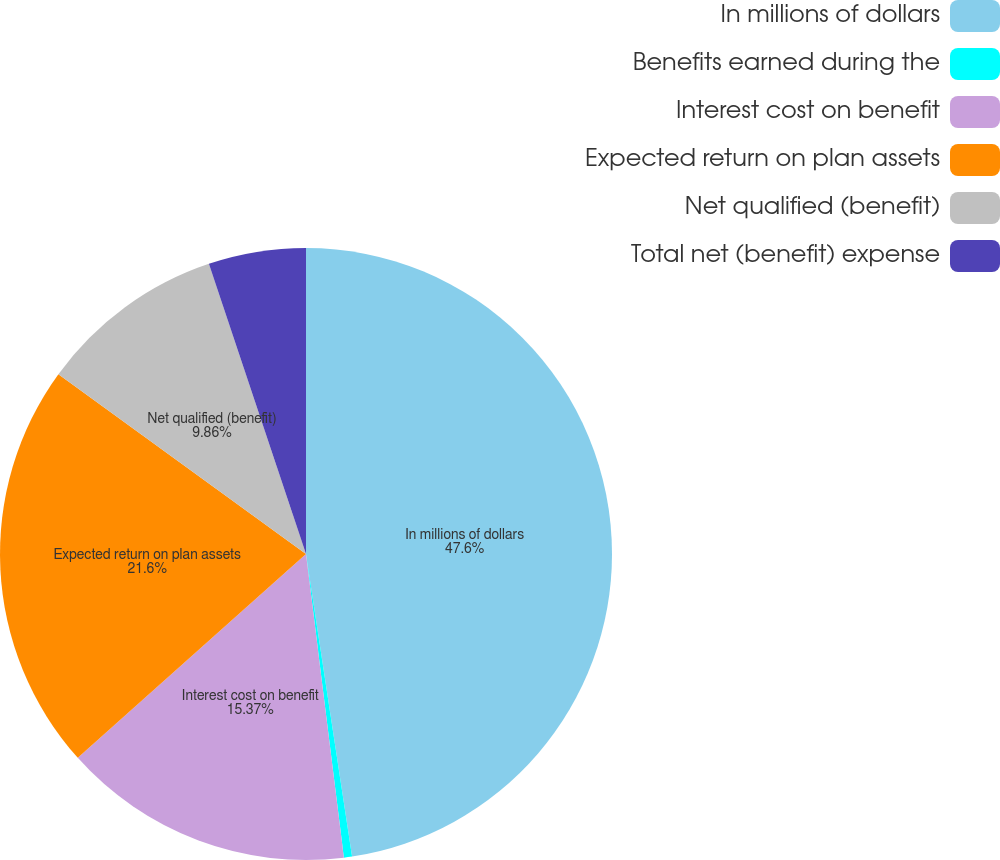Convert chart to OTSL. <chart><loc_0><loc_0><loc_500><loc_500><pie_chart><fcel>In millions of dollars<fcel>Benefits earned during the<fcel>Interest cost on benefit<fcel>Expected return on plan assets<fcel>Net qualified (benefit)<fcel>Total net (benefit) expense<nl><fcel>47.59%<fcel>0.43%<fcel>15.37%<fcel>21.6%<fcel>9.86%<fcel>5.14%<nl></chart> 